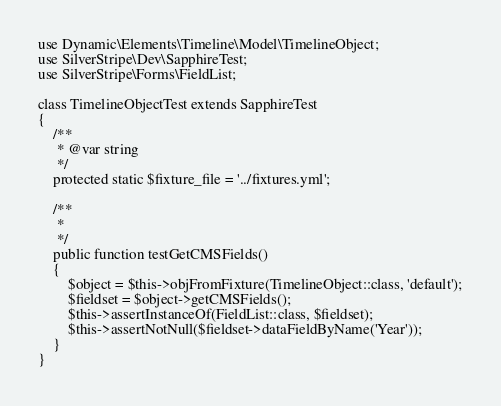<code> <loc_0><loc_0><loc_500><loc_500><_PHP_>
use Dynamic\Elements\Timeline\Model\TimelineObject;
use SilverStripe\Dev\SapphireTest;
use SilverStripe\Forms\FieldList;

class TimelineObjectTest extends SapphireTest
{
    /**
     * @var string
     */
    protected static $fixture_file = '../fixtures.yml';

    /**
     *
     */
    public function testGetCMSFields()
    {
        $object = $this->objFromFixture(TimelineObject::class, 'default');
        $fieldset = $object->getCMSFields();
        $this->assertInstanceOf(FieldList::class, $fieldset);
        $this->assertNotNull($fieldset->dataFieldByName('Year'));
    }
}
</code> 